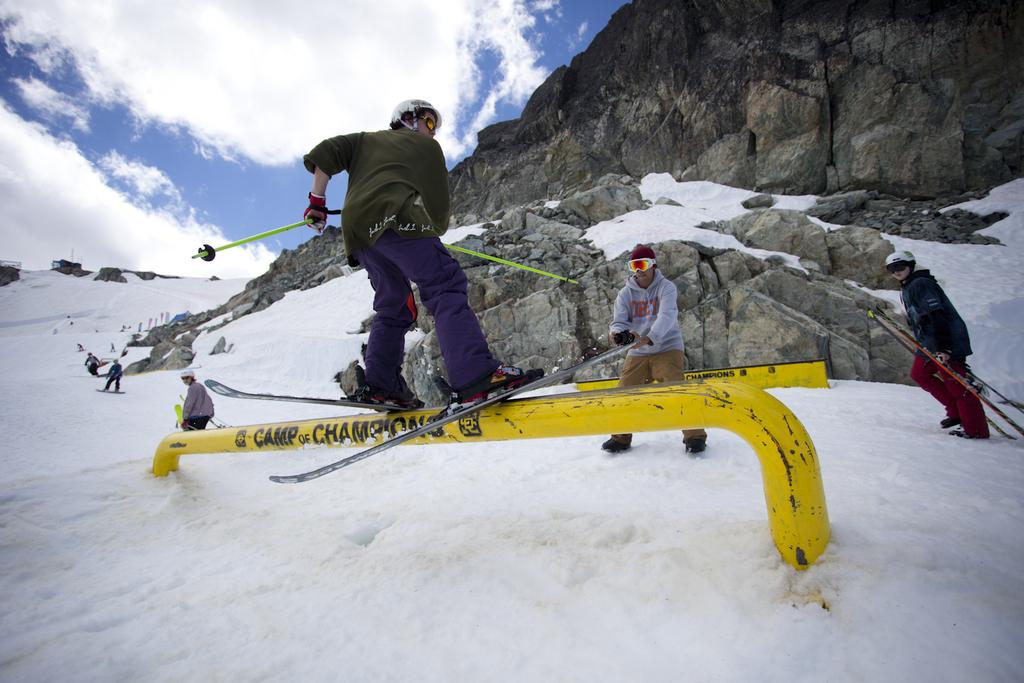What are the persons in the image doing? The persons in the image are standing on ski boards. What is the condition of the ground in the image? The ground is covered in snow. What can be seen in the background of the image? There is a mountain and the sky visible in the background. What is the weather like in the image? The sky has heavy clouds, suggesting it might be snowing or overcast. Can you tell me how many tigers are hiding in the cave in the image? There are no tigers or caves present in the image; it features persons skiing on snow-covered ground with a mountain and heavy clouds in the background. 